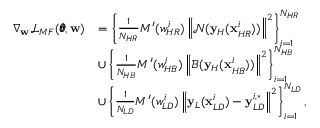<formula> <loc_0><loc_0><loc_500><loc_500>\begin{array} { r l } { \nabla _ { w } \mathcal { L } _ { M F } ( \pm b { \theta } , w ) } & { = \left \{ \frac { 1 } { N _ { H R } } { M ^ { \prime } ( w _ { H R } ^ { i } ) \left \| \mathcal { N } ( y _ { H } ( x _ { H R } ^ { i } ) ) \right \| ^ { 2 } } \right \} _ { i = 1 } ^ { N _ { H R } } } \\ & { \cup \left \{ \frac { 1 } { N _ { H B } } { M ^ { \prime } ( w _ { H B } ^ { i } ) \left \| \mathcal { B } ( y _ { H } ( x _ { H B } ^ { i } ) ) \right \| ^ { 2 } } \right \} _ { i = 1 } ^ { N _ { H B } } } \\ & { \cup \left \{ \frac { 1 } { N _ { L D } } { M ^ { \prime } ( w _ { L D } ^ { i } ) \left \| y _ { L } ( x _ { L D } ^ { i } ) - y _ { L D } ^ { i , * } \right \| ^ { 2 } } \right \} _ { i = 1 } ^ { N _ { L D } } , } \end{array}</formula> 